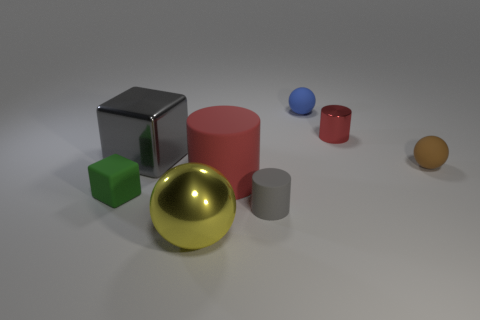What number of matte things are either large gray things or red things?
Your answer should be very brief. 1. What is the shape of the small thing that is the same color as the big rubber cylinder?
Provide a succinct answer. Cylinder. What number of yellow shiny objects have the same size as the brown ball?
Provide a succinct answer. 0. There is a object that is both on the left side of the large cylinder and in front of the tiny green thing; what color is it?
Give a very brief answer. Yellow. What number of objects are either rubber balls or large red matte things?
Give a very brief answer. 3. How many tiny objects are gray cubes or green things?
Your answer should be compact. 1. Is there anything else of the same color as the small block?
Your answer should be very brief. No. There is a ball that is in front of the small blue matte thing and behind the metallic sphere; how big is it?
Provide a short and direct response. Small. There is a tiny matte ball right of the tiny red metal cylinder; is its color the same as the rubber cylinder in front of the green block?
Your answer should be compact. No. How many other things are the same material as the large yellow ball?
Give a very brief answer. 2. 